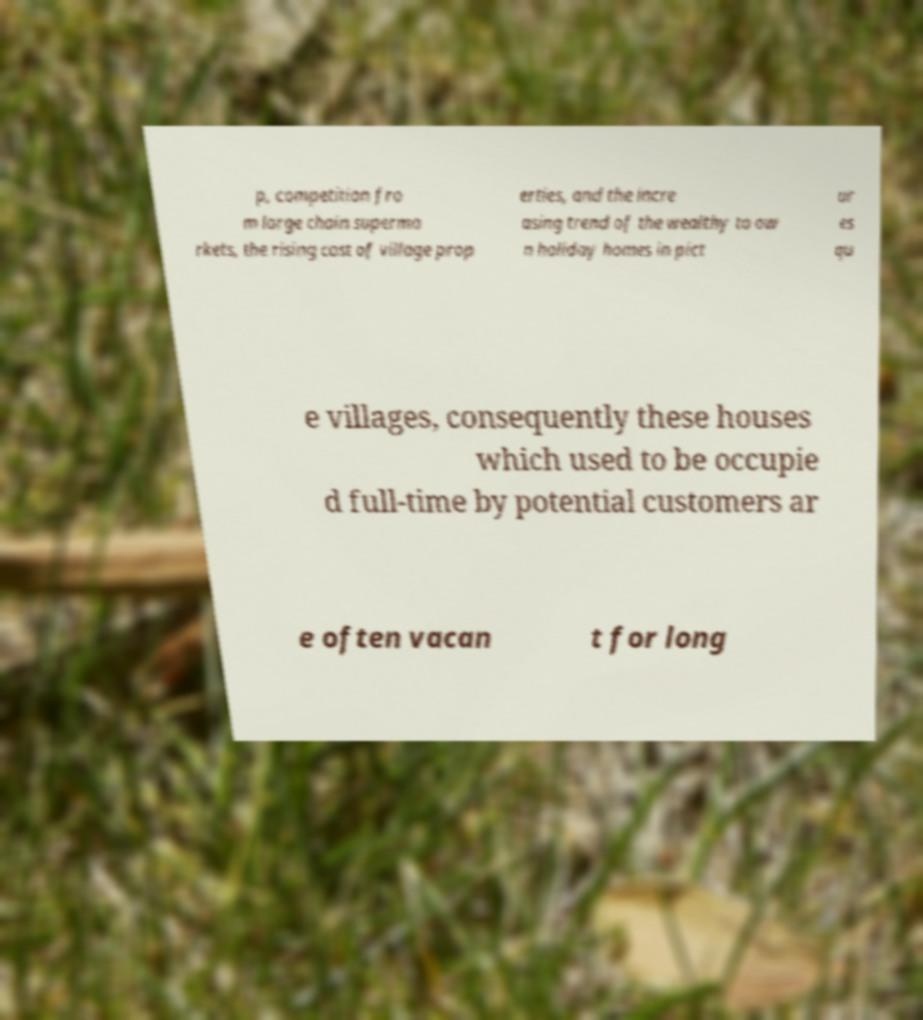There's text embedded in this image that I need extracted. Can you transcribe it verbatim? p, competition fro m large chain superma rkets, the rising cost of village prop erties, and the incre asing trend of the wealthy to ow n holiday homes in pict ur es qu e villages, consequently these houses which used to be occupie d full-time by potential customers ar e often vacan t for long 